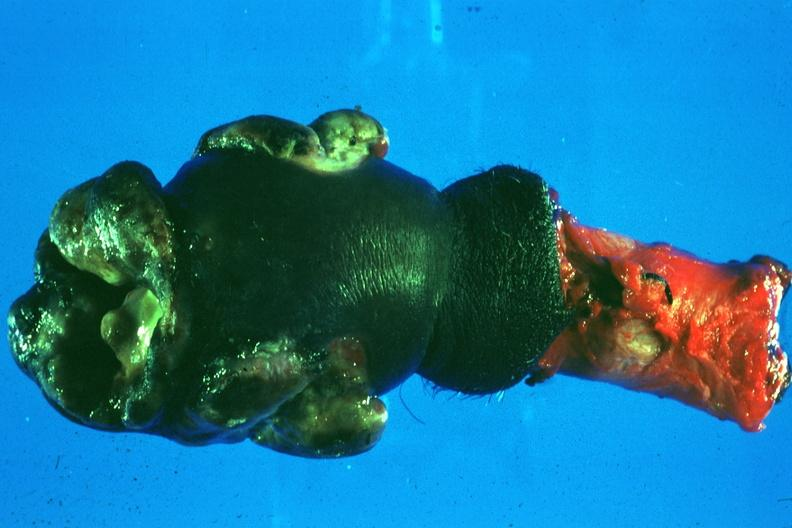does this image show excised penis with nodular masses of tumor?
Answer the question using a single word or phrase. Yes 